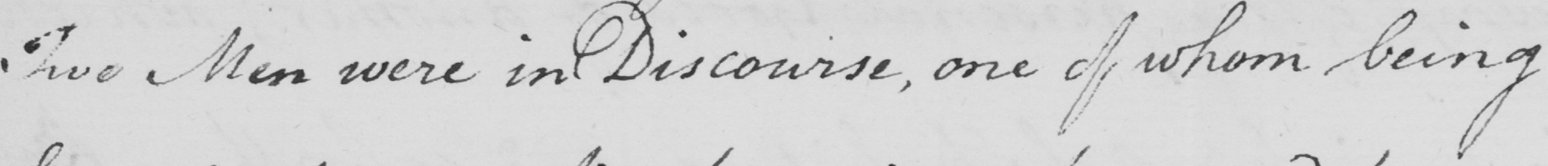Transcribe the text shown in this historical manuscript line. Five Men were in Discourse , one of whom being 